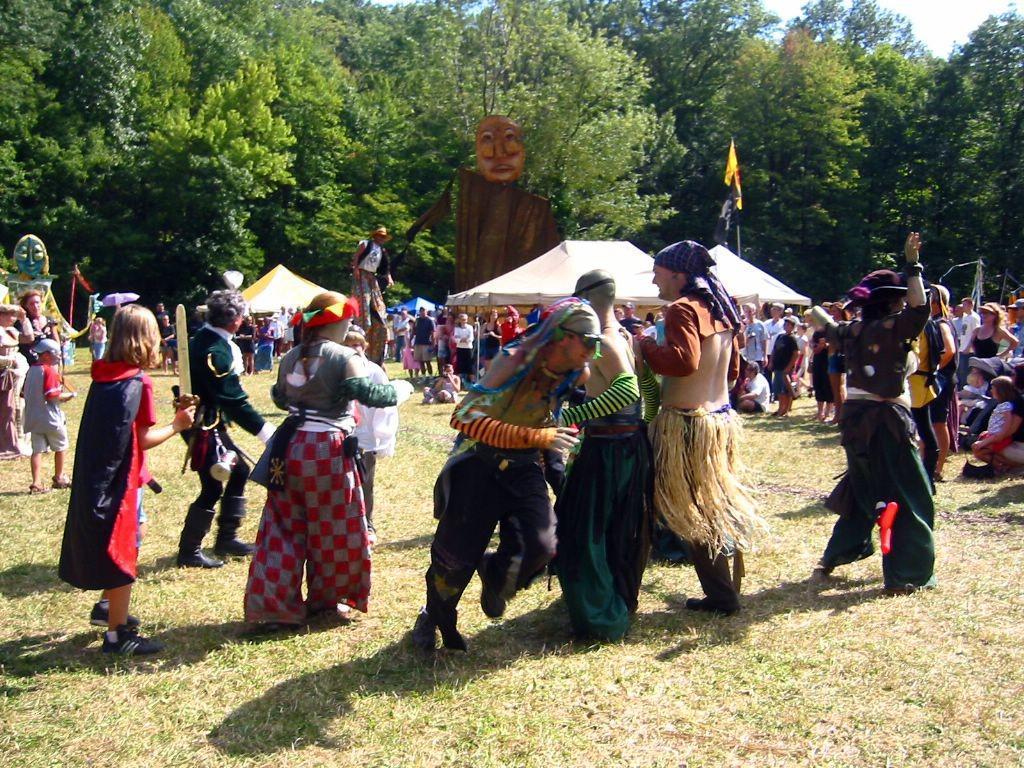Describe this image in one or two sentences. In this image there are group of people standing on the ground by wearing different costumes. In the background there are trees. In between them there are tents under which there are some people sitting on the ground. At the top there is sky. 